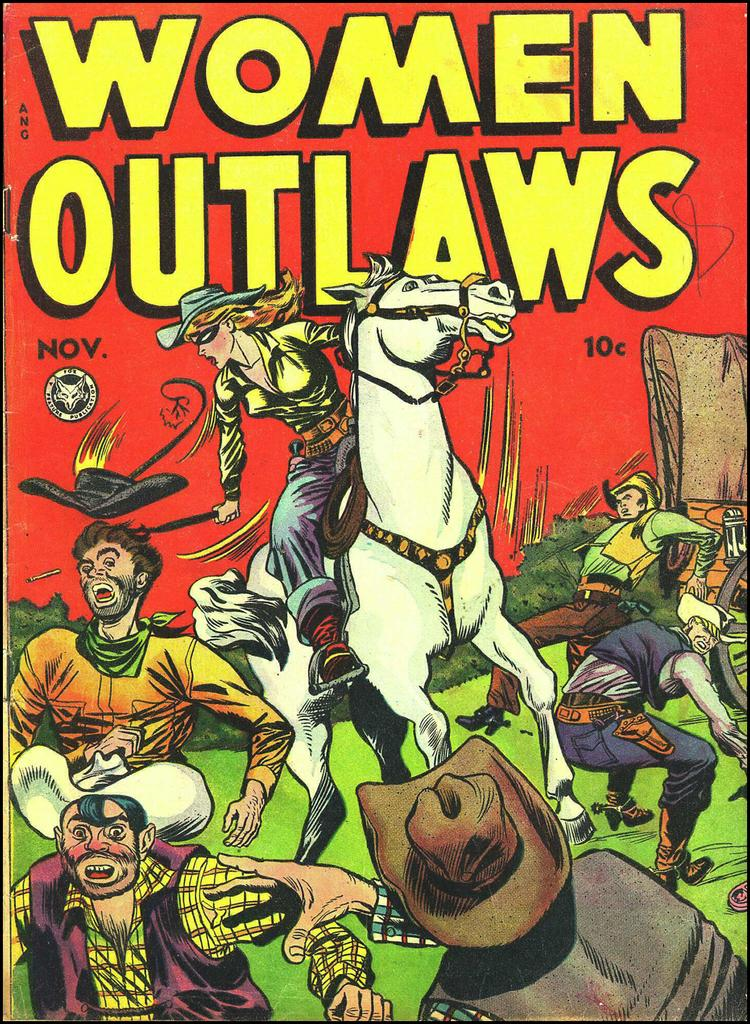<image>
Present a compact description of the photo's key features. A cartoon depiction of a woman riding a horse with the title Women Outlaws above her. 